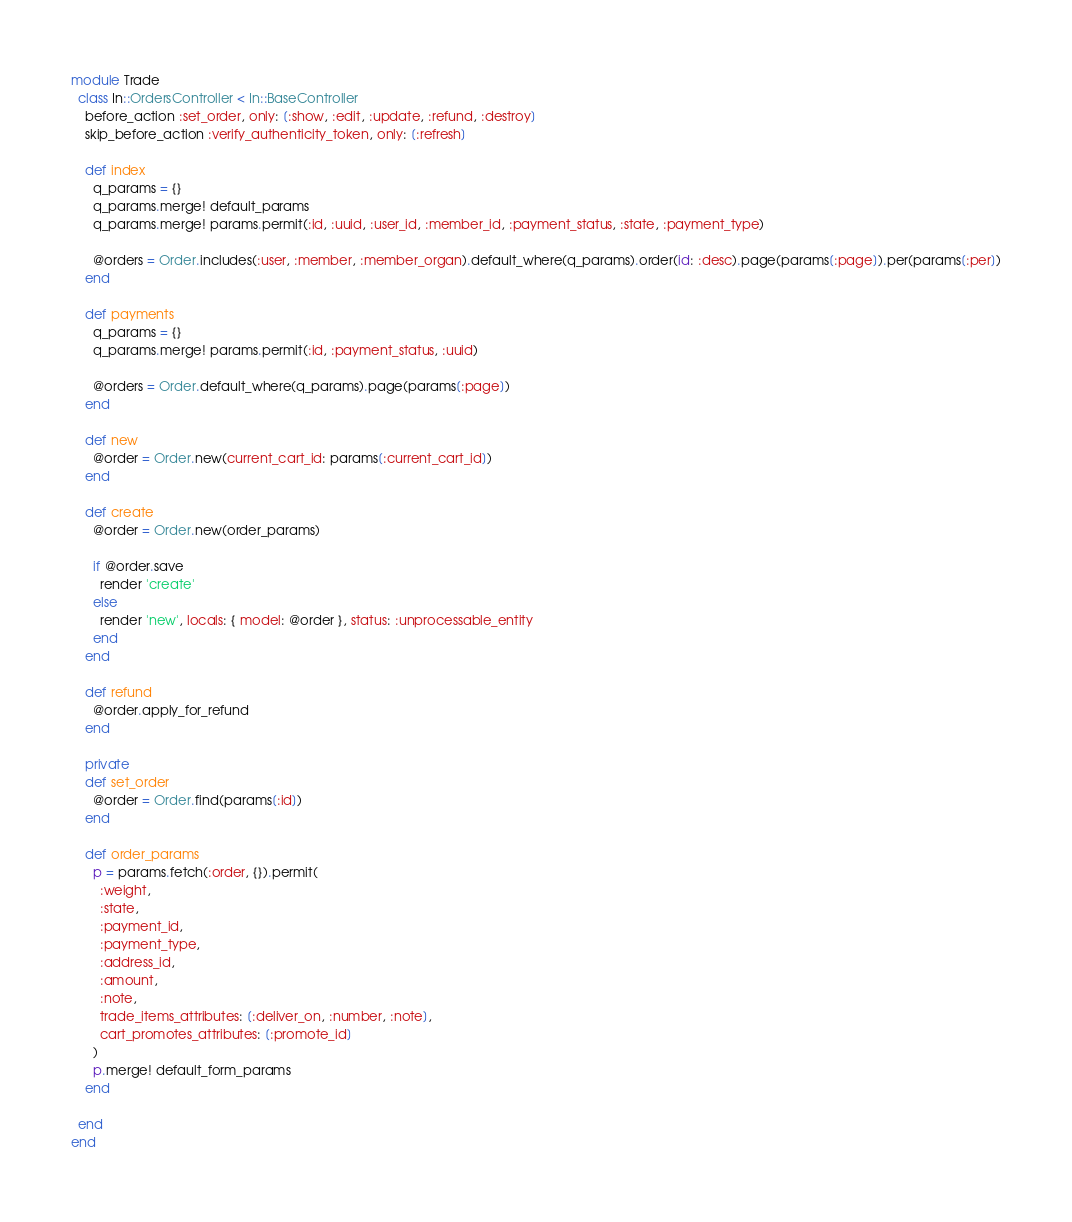Convert code to text. <code><loc_0><loc_0><loc_500><loc_500><_Ruby_>module Trade
  class In::OrdersController < In::BaseController
    before_action :set_order, only: [:show, :edit, :update, :refund, :destroy]
    skip_before_action :verify_authenticity_token, only: [:refresh]

    def index
      q_params = {}
      q_params.merge! default_params
      q_params.merge! params.permit(:id, :uuid, :user_id, :member_id, :payment_status, :state, :payment_type)

      @orders = Order.includes(:user, :member, :member_organ).default_where(q_params).order(id: :desc).page(params[:page]).per(params[:per])
    end

    def payments
      q_params = {}
      q_params.merge! params.permit(:id, :payment_status, :uuid)

      @orders = Order.default_where(q_params).page(params[:page])
    end

    def new
      @order = Order.new(current_cart_id: params[:current_cart_id])
    end

    def create
      @order = Order.new(order_params)

      if @order.save
        render 'create'
      else
        render 'new', locals: { model: @order }, status: :unprocessable_entity
      end
    end

    def refund
      @order.apply_for_refund
    end

    private
    def set_order
      @order = Order.find(params[:id])
    end

    def order_params
      p = params.fetch(:order, {}).permit(
        :weight,
        :state,
        :payment_id,
        :payment_type,
        :address_id,
        :amount,
        :note,
        trade_items_attributes: [:deliver_on, :number, :note],
        cart_promotes_attributes: [:promote_id]
      )
      p.merge! default_form_params
    end

  end
end
</code> 